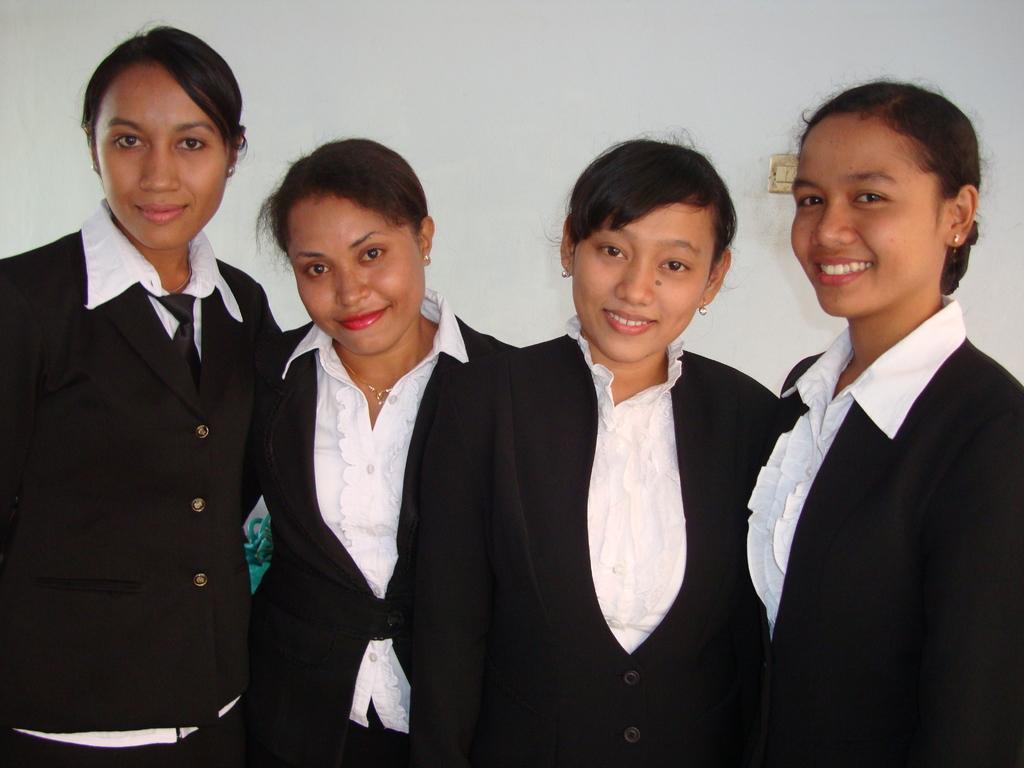How would you summarize this image in a sentence or two? In this image we can see four ladies standing and smiling. In the back there is a wall. 